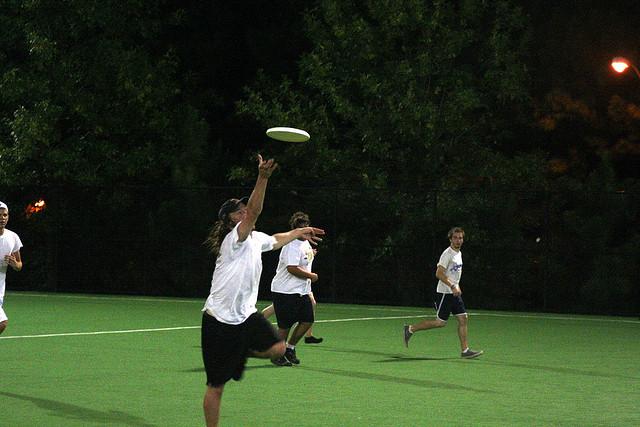What is the man catching?
Give a very brief answer. Frisbee. How many people on the field?
Keep it brief. 5. What sport is shown?
Write a very short answer. Frisbee. 